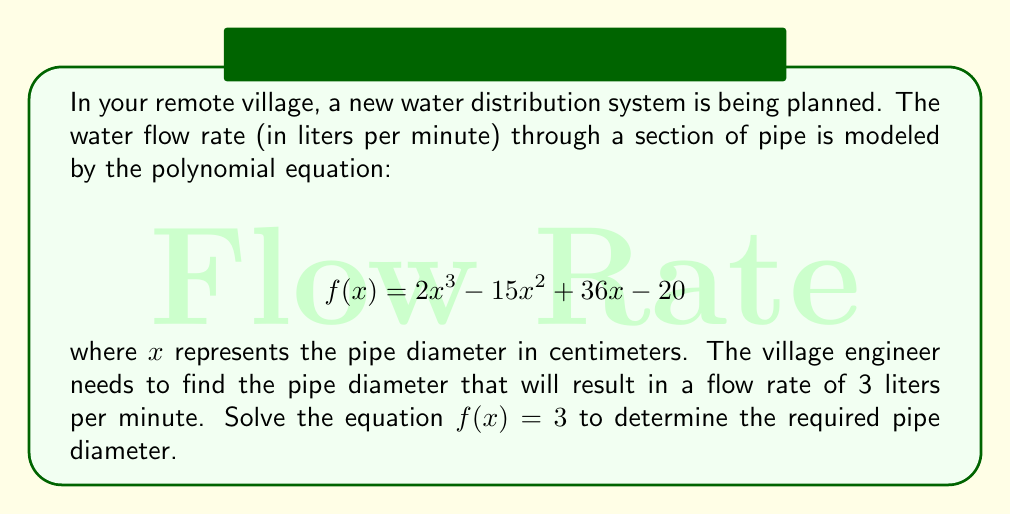Give your solution to this math problem. To solve this problem, we need to follow these steps:

1) First, we set up the equation:
   $$ 2x^3 - 15x^2 + 36x - 20 = 3 $$

2) Subtract 3 from both sides to get the equation in standard form:
   $$ 2x^3 - 15x^2 + 36x - 23 = 0 $$

3) This is a cubic equation. One way to solve it is by factoring. Let's try to guess one solution. Given the constant term is -23, possible factors could be 1 or -1.

4) By testing, we find that x = 1 is a solution. So (x - 1) is a factor.

5) We can use polynomial long division to find the other factor:

   $$ \frac{2x^3 - 15x^2 + 36x - 23}{x - 1} = 2x^2 - 13x + 23 $$

6) So our equation becomes:
   $$ (x - 1)(2x^2 - 13x + 23) = 0 $$

7) We can solve this using the quadratic formula on the second factor:
   $$ x = \frac{13 \pm \sqrt{13^2 - 4(2)(23)}}{2(2)} $$

8) Simplifying:
   $$ x = \frac{13 \pm \sqrt{169 - 184}}{4} = \frac{13 \pm \sqrt{-15}}{4} $$

9) Since we're dealing with real pipe diameters, we can discard the complex solutions.

Therefore, the only real solution is x = 1.
Answer: 1 cm 